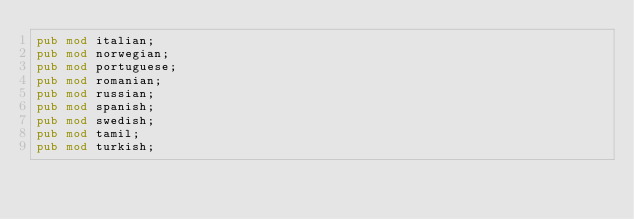<code> <loc_0><loc_0><loc_500><loc_500><_Rust_>pub mod italian;
pub mod norwegian;
pub mod portuguese;
pub mod romanian;
pub mod russian;
pub mod spanish;
pub mod swedish;
pub mod tamil;
pub mod turkish;
</code> 